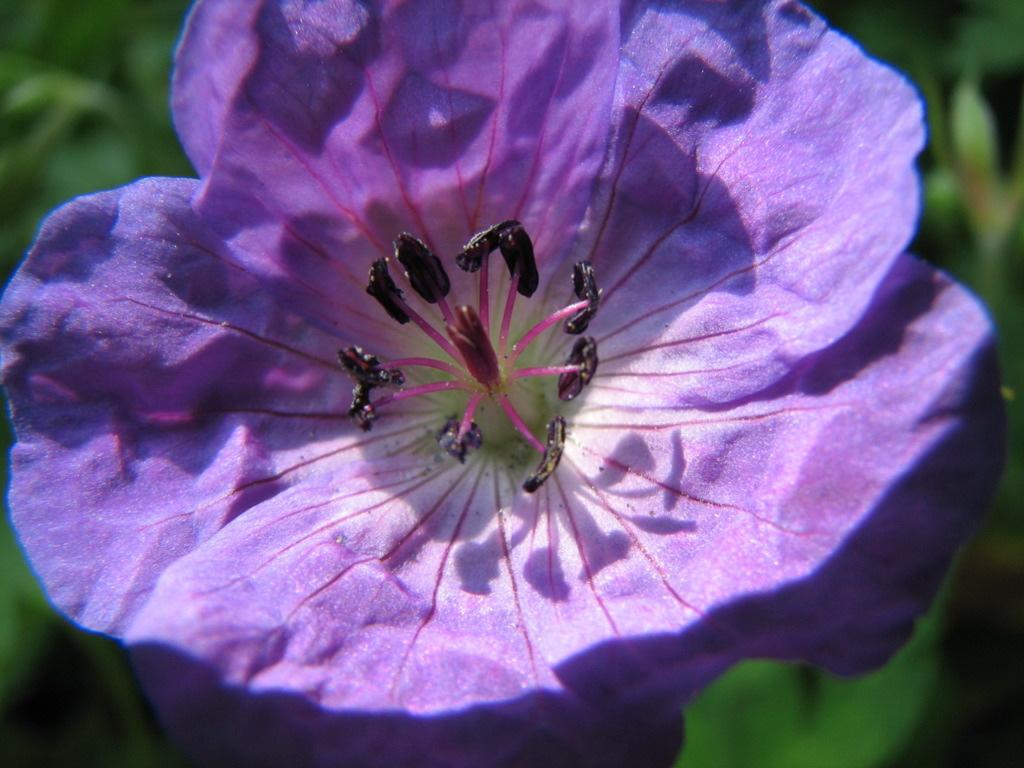What color is the flower in the image? The flower in the image is purple. What can be found inside the flower? Pollen grains are present in the flower. How many mice are hiding behind the flower in the image? There are no mice present in the image. What sound does the bell make when it is rung in the image? There is no bell present in the image. 